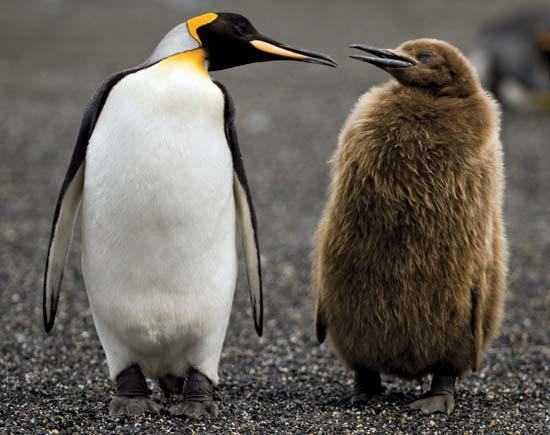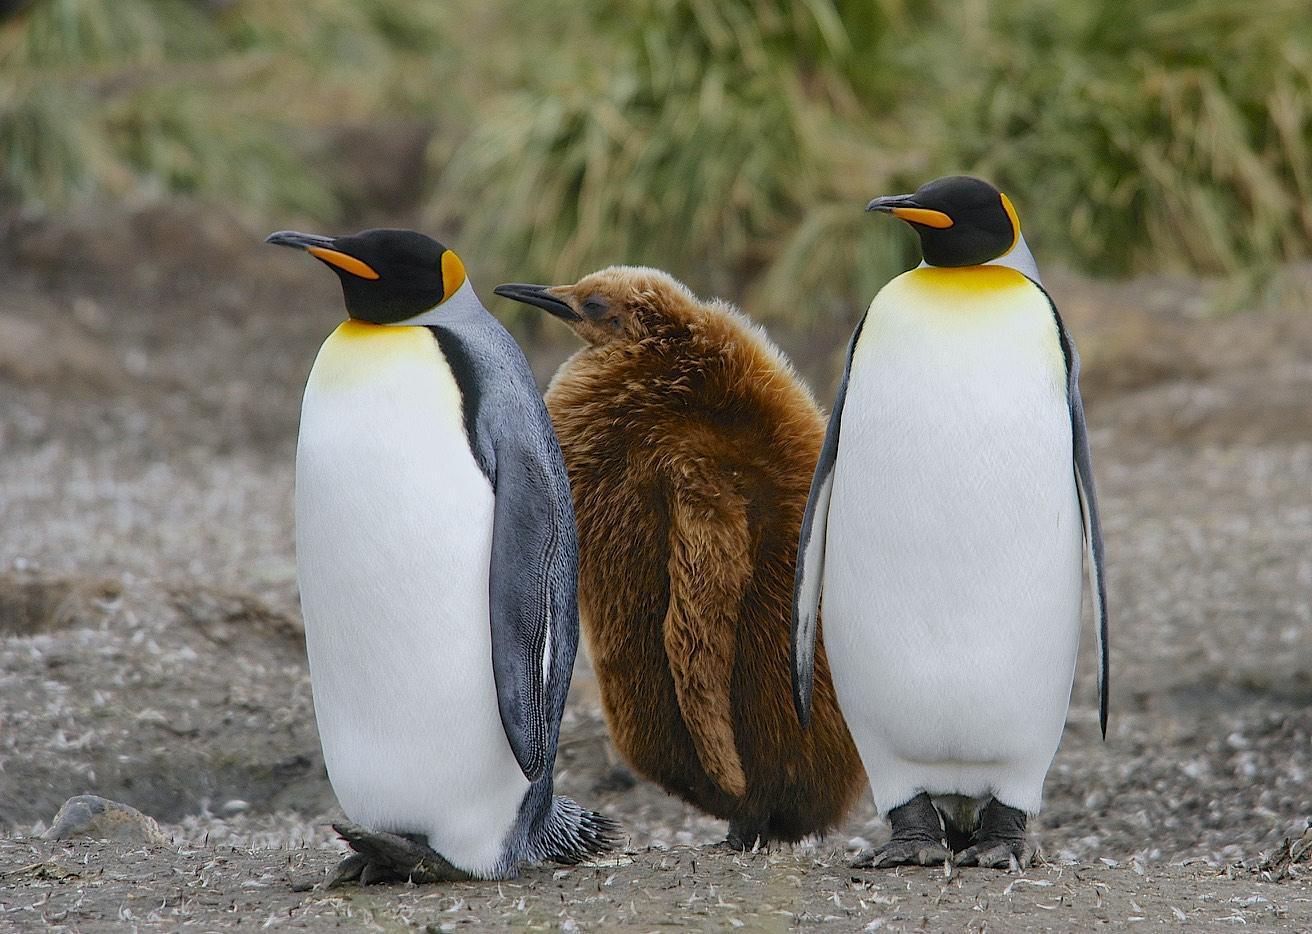The first image is the image on the left, the second image is the image on the right. Evaluate the accuracy of this statement regarding the images: "There are no more than five penguins". Is it true? Answer yes or no. Yes. 